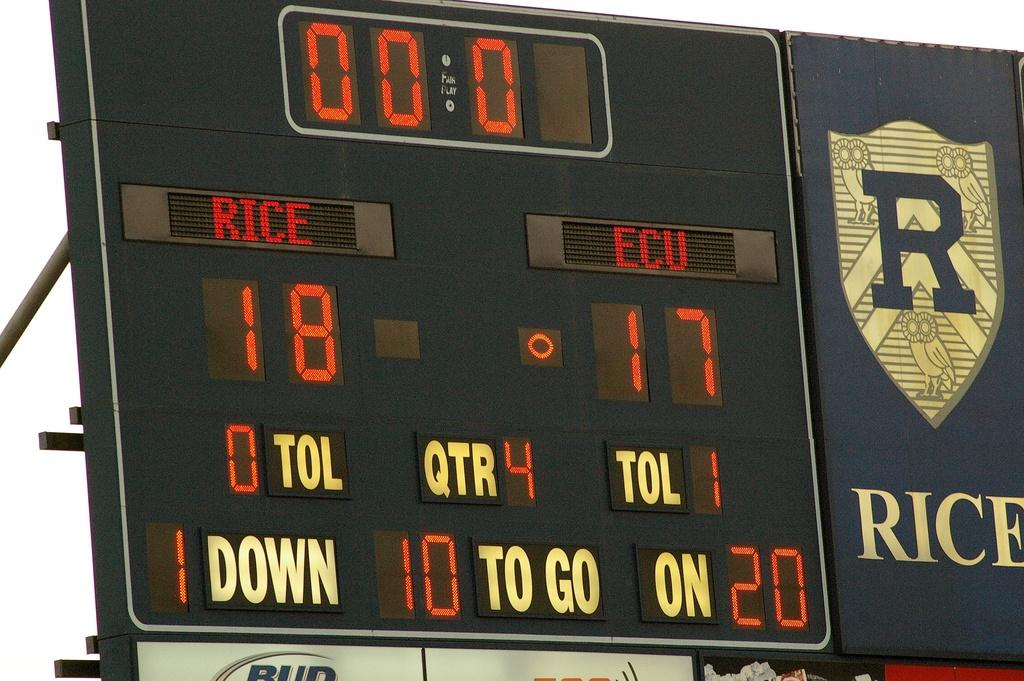<image>
Offer a succinct explanation of the picture presented. the number 17 is on the scoreboard with the word rice on it 